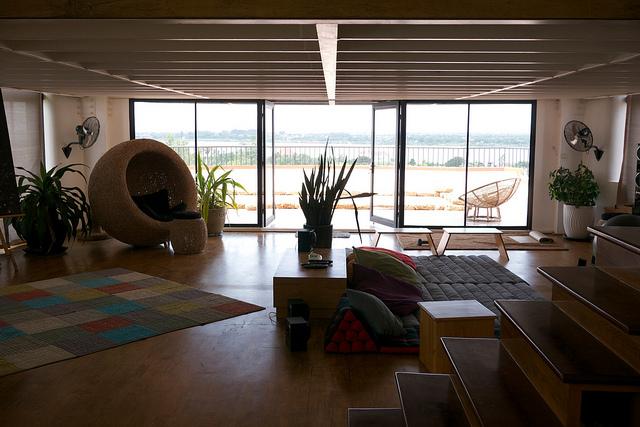Is the owner of this home poor?
Answer briefly. No. How many red squares can you see on the rug?
Concise answer only. 4. What kind of chair is just outside?
Answer briefly. Round chair. 